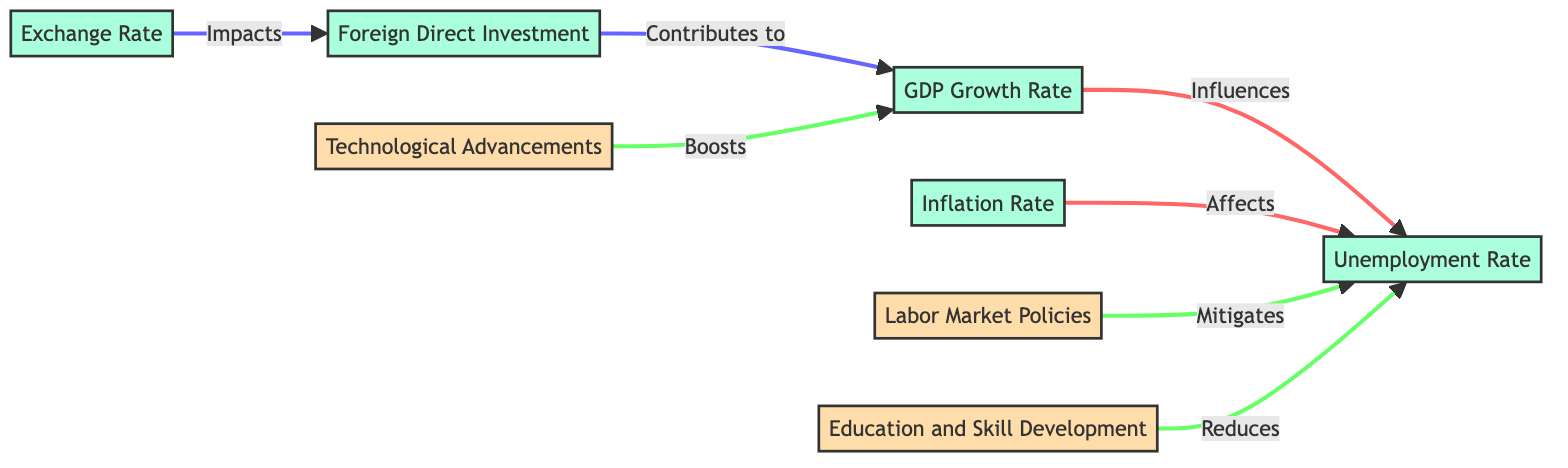What influences the unemployment rate? The diagram shows that the GDP Growth Rate influences the Unemployment Rate as indicated by the arrow labeled "Influences" from the GDP Growth Rate to the Unemployment Rate.
Answer: GDP Growth Rate How many nodes are in the diagram? The diagram lists 8 distinct economic indicators or factors as nodes. Counting these nodes gives us the total number, which is 8.
Answer: 8 Which node contributes to the GDP Growth Rate? The diagram indicates that Foreign Direct Investment contributes to the GDP Growth Rate, as shown by the "Contributes to" label connecting Foreign Direct Investment to GDP Growth Rate.
Answer: Foreign Direct Investment What mitigates the unemployment rate? The diagram shows that Labor Market Policies mitigate the Unemployment Rate, as indicated by the arrow labeled "Mitigates" pointing from Labor Market Policies to Unemployment Rate.
Answer: Labor Market Policies Which factor has a direct impact on Foreign Direct Investment? The diagram reveals that the Exchange Rate impacts Foreign Direct Investment, demonstrated by the connection labeled "Impacts" from Exchange Rate to Foreign Direct Investment.
Answer: Exchange Rate What reduces the unemployment rate? The diagram clearly states that Education and Skill Development reduces the Unemployment Rate, as indicated by the "Reduces" label connecting Education and Skill Development to the Unemployment Rate.
Answer: Education and Skill Development What boosts the GDP Growth Rate? According to the diagram, Technological Advancements boost the GDP Growth Rate, evidenced by the arrow labeled "Boosts" from Technological Advancements to GDP Growth Rate.
Answer: Technological Advancements What are the total edges in the diagram? The diagram establishes 6 distinct connections (edges) between nodes, expressing various influences and contributions, so the total number of edges is 6.
Answer: 6 Which economic indicator is linked to both GDP Growth Rate and Unemployment Rate? The Unemployment Rate is connected to the GDP Growth Rate and is also influenced by the Inflation Rate, depicted by two arrows leading to it from different nodes.
Answer: Unemployment Rate 